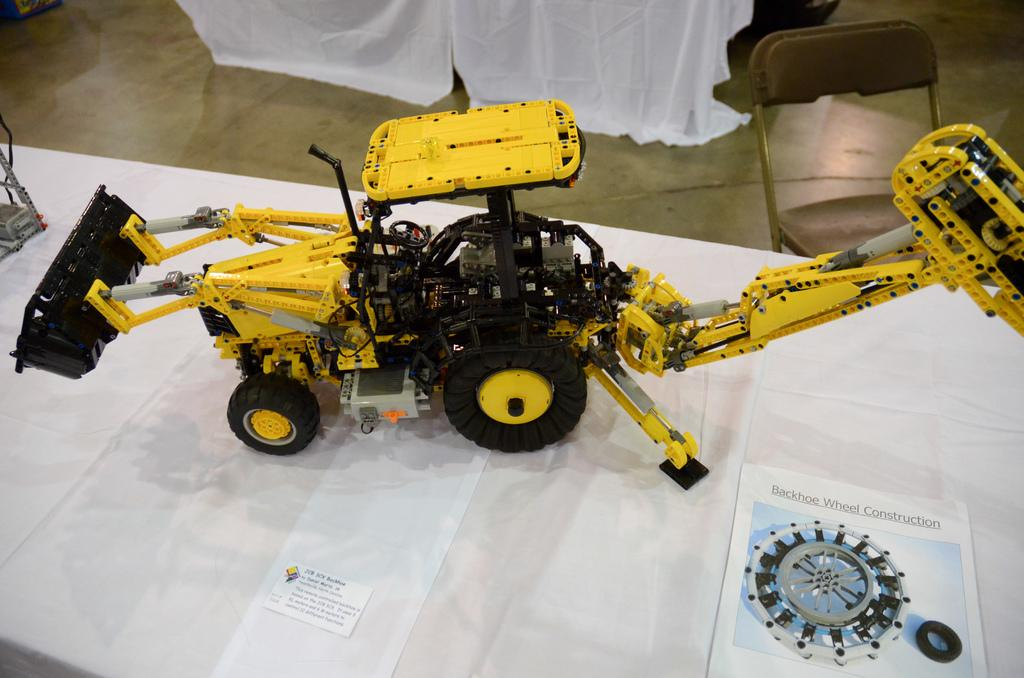What type of toy is on the table in the image? There is a toy crane on the table. What is covering the table in the image? There is a white cloth on the table. What is placed on top of the white cloth? There are papers on the white cloth. Can you describe the background of the image? There is a chair in the background. What type of wax is being melted by the toy crane in the image? There is no wax being melted in the image; the toy crane is not interacting with any wax. 